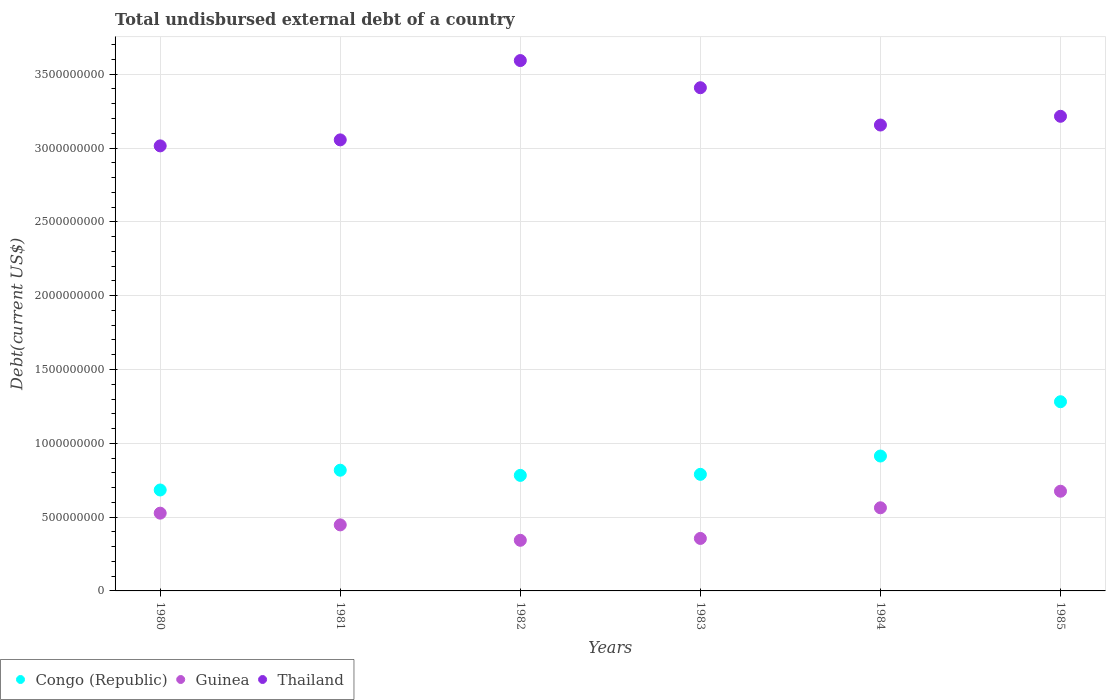What is the total undisbursed external debt in Congo (Republic) in 1985?
Provide a succinct answer. 1.28e+09. Across all years, what is the maximum total undisbursed external debt in Congo (Republic)?
Give a very brief answer. 1.28e+09. Across all years, what is the minimum total undisbursed external debt in Thailand?
Ensure brevity in your answer.  3.01e+09. In which year was the total undisbursed external debt in Thailand maximum?
Provide a short and direct response. 1982. In which year was the total undisbursed external debt in Guinea minimum?
Offer a very short reply. 1982. What is the total total undisbursed external debt in Thailand in the graph?
Your answer should be compact. 1.94e+1. What is the difference between the total undisbursed external debt in Congo (Republic) in 1983 and that in 1984?
Ensure brevity in your answer.  -1.24e+08. What is the difference between the total undisbursed external debt in Congo (Republic) in 1984 and the total undisbursed external debt in Guinea in 1985?
Provide a succinct answer. 2.38e+08. What is the average total undisbursed external debt in Guinea per year?
Offer a terse response. 4.85e+08. In the year 1984, what is the difference between the total undisbursed external debt in Thailand and total undisbursed external debt in Congo (Republic)?
Give a very brief answer. 2.24e+09. In how many years, is the total undisbursed external debt in Congo (Republic) greater than 1300000000 US$?
Offer a terse response. 0. What is the ratio of the total undisbursed external debt in Congo (Republic) in 1980 to that in 1981?
Your response must be concise. 0.84. Is the total undisbursed external debt in Guinea in 1980 less than that in 1983?
Make the answer very short. No. What is the difference between the highest and the second highest total undisbursed external debt in Guinea?
Your response must be concise. 1.12e+08. What is the difference between the highest and the lowest total undisbursed external debt in Guinea?
Give a very brief answer. 3.32e+08. Is the sum of the total undisbursed external debt in Congo (Republic) in 1980 and 1981 greater than the maximum total undisbursed external debt in Guinea across all years?
Make the answer very short. Yes. Is the total undisbursed external debt in Guinea strictly less than the total undisbursed external debt in Thailand over the years?
Keep it short and to the point. Yes. What is the difference between two consecutive major ticks on the Y-axis?
Give a very brief answer. 5.00e+08. Are the values on the major ticks of Y-axis written in scientific E-notation?
Make the answer very short. No. Does the graph contain any zero values?
Your response must be concise. No. How many legend labels are there?
Your answer should be compact. 3. How are the legend labels stacked?
Give a very brief answer. Horizontal. What is the title of the graph?
Your answer should be very brief. Total undisbursed external debt of a country. What is the label or title of the X-axis?
Your answer should be compact. Years. What is the label or title of the Y-axis?
Give a very brief answer. Debt(current US$). What is the Debt(current US$) of Congo (Republic) in 1980?
Your answer should be very brief. 6.84e+08. What is the Debt(current US$) in Guinea in 1980?
Offer a very short reply. 5.27e+08. What is the Debt(current US$) in Thailand in 1980?
Your answer should be very brief. 3.01e+09. What is the Debt(current US$) in Congo (Republic) in 1981?
Your answer should be very brief. 8.18e+08. What is the Debt(current US$) in Guinea in 1981?
Ensure brevity in your answer.  4.47e+08. What is the Debt(current US$) of Thailand in 1981?
Make the answer very short. 3.06e+09. What is the Debt(current US$) of Congo (Republic) in 1982?
Give a very brief answer. 7.83e+08. What is the Debt(current US$) in Guinea in 1982?
Provide a short and direct response. 3.43e+08. What is the Debt(current US$) of Thailand in 1982?
Your answer should be very brief. 3.59e+09. What is the Debt(current US$) of Congo (Republic) in 1983?
Offer a terse response. 7.90e+08. What is the Debt(current US$) of Guinea in 1983?
Your answer should be compact. 3.56e+08. What is the Debt(current US$) of Thailand in 1983?
Make the answer very short. 3.41e+09. What is the Debt(current US$) in Congo (Republic) in 1984?
Make the answer very short. 9.14e+08. What is the Debt(current US$) of Guinea in 1984?
Your answer should be very brief. 5.63e+08. What is the Debt(current US$) of Thailand in 1984?
Make the answer very short. 3.16e+09. What is the Debt(current US$) in Congo (Republic) in 1985?
Ensure brevity in your answer.  1.28e+09. What is the Debt(current US$) in Guinea in 1985?
Your response must be concise. 6.75e+08. What is the Debt(current US$) of Thailand in 1985?
Offer a very short reply. 3.21e+09. Across all years, what is the maximum Debt(current US$) of Congo (Republic)?
Keep it short and to the point. 1.28e+09. Across all years, what is the maximum Debt(current US$) of Guinea?
Your response must be concise. 6.75e+08. Across all years, what is the maximum Debt(current US$) of Thailand?
Your answer should be very brief. 3.59e+09. Across all years, what is the minimum Debt(current US$) in Congo (Republic)?
Your answer should be very brief. 6.84e+08. Across all years, what is the minimum Debt(current US$) in Guinea?
Your answer should be compact. 3.43e+08. Across all years, what is the minimum Debt(current US$) in Thailand?
Your answer should be very brief. 3.01e+09. What is the total Debt(current US$) in Congo (Republic) in the graph?
Your answer should be compact. 5.27e+09. What is the total Debt(current US$) of Guinea in the graph?
Your answer should be very brief. 2.91e+09. What is the total Debt(current US$) in Thailand in the graph?
Your answer should be very brief. 1.94e+1. What is the difference between the Debt(current US$) in Congo (Republic) in 1980 and that in 1981?
Your answer should be very brief. -1.34e+08. What is the difference between the Debt(current US$) of Guinea in 1980 and that in 1981?
Your answer should be compact. 7.94e+07. What is the difference between the Debt(current US$) of Thailand in 1980 and that in 1981?
Your answer should be very brief. -4.07e+07. What is the difference between the Debt(current US$) in Congo (Republic) in 1980 and that in 1982?
Keep it short and to the point. -9.89e+07. What is the difference between the Debt(current US$) in Guinea in 1980 and that in 1982?
Your response must be concise. 1.84e+08. What is the difference between the Debt(current US$) in Thailand in 1980 and that in 1982?
Keep it short and to the point. -5.78e+08. What is the difference between the Debt(current US$) in Congo (Republic) in 1980 and that in 1983?
Your answer should be compact. -1.06e+08. What is the difference between the Debt(current US$) of Guinea in 1980 and that in 1983?
Offer a very short reply. 1.71e+08. What is the difference between the Debt(current US$) of Thailand in 1980 and that in 1983?
Your answer should be compact. -3.94e+08. What is the difference between the Debt(current US$) in Congo (Republic) in 1980 and that in 1984?
Make the answer very short. -2.30e+08. What is the difference between the Debt(current US$) in Guinea in 1980 and that in 1984?
Your response must be concise. -3.64e+07. What is the difference between the Debt(current US$) of Thailand in 1980 and that in 1984?
Your answer should be compact. -1.41e+08. What is the difference between the Debt(current US$) in Congo (Republic) in 1980 and that in 1985?
Keep it short and to the point. -5.98e+08. What is the difference between the Debt(current US$) in Guinea in 1980 and that in 1985?
Your answer should be compact. -1.49e+08. What is the difference between the Debt(current US$) of Thailand in 1980 and that in 1985?
Ensure brevity in your answer.  -2.00e+08. What is the difference between the Debt(current US$) of Congo (Republic) in 1981 and that in 1982?
Keep it short and to the point. 3.50e+07. What is the difference between the Debt(current US$) in Guinea in 1981 and that in 1982?
Keep it short and to the point. 1.04e+08. What is the difference between the Debt(current US$) in Thailand in 1981 and that in 1982?
Make the answer very short. -5.37e+08. What is the difference between the Debt(current US$) of Congo (Republic) in 1981 and that in 1983?
Your response must be concise. 2.79e+07. What is the difference between the Debt(current US$) in Guinea in 1981 and that in 1983?
Make the answer very short. 9.18e+07. What is the difference between the Debt(current US$) of Thailand in 1981 and that in 1983?
Provide a short and direct response. -3.53e+08. What is the difference between the Debt(current US$) of Congo (Republic) in 1981 and that in 1984?
Give a very brief answer. -9.61e+07. What is the difference between the Debt(current US$) of Guinea in 1981 and that in 1984?
Your response must be concise. -1.16e+08. What is the difference between the Debt(current US$) in Thailand in 1981 and that in 1984?
Provide a short and direct response. -1.01e+08. What is the difference between the Debt(current US$) in Congo (Republic) in 1981 and that in 1985?
Offer a terse response. -4.64e+08. What is the difference between the Debt(current US$) in Guinea in 1981 and that in 1985?
Give a very brief answer. -2.28e+08. What is the difference between the Debt(current US$) of Thailand in 1981 and that in 1985?
Your answer should be compact. -1.60e+08. What is the difference between the Debt(current US$) in Congo (Republic) in 1982 and that in 1983?
Your answer should be very brief. -7.10e+06. What is the difference between the Debt(current US$) of Guinea in 1982 and that in 1983?
Your answer should be compact. -1.27e+07. What is the difference between the Debt(current US$) of Thailand in 1982 and that in 1983?
Make the answer very short. 1.84e+08. What is the difference between the Debt(current US$) in Congo (Republic) in 1982 and that in 1984?
Ensure brevity in your answer.  -1.31e+08. What is the difference between the Debt(current US$) in Guinea in 1982 and that in 1984?
Provide a short and direct response. -2.20e+08. What is the difference between the Debt(current US$) in Thailand in 1982 and that in 1984?
Offer a terse response. 4.37e+08. What is the difference between the Debt(current US$) in Congo (Republic) in 1982 and that in 1985?
Provide a succinct answer. -4.99e+08. What is the difference between the Debt(current US$) in Guinea in 1982 and that in 1985?
Offer a terse response. -3.32e+08. What is the difference between the Debt(current US$) in Thailand in 1982 and that in 1985?
Provide a succinct answer. 3.77e+08. What is the difference between the Debt(current US$) of Congo (Republic) in 1983 and that in 1984?
Keep it short and to the point. -1.24e+08. What is the difference between the Debt(current US$) of Guinea in 1983 and that in 1984?
Keep it short and to the point. -2.08e+08. What is the difference between the Debt(current US$) in Thailand in 1983 and that in 1984?
Offer a very short reply. 2.53e+08. What is the difference between the Debt(current US$) of Congo (Republic) in 1983 and that in 1985?
Your answer should be very brief. -4.92e+08. What is the difference between the Debt(current US$) in Guinea in 1983 and that in 1985?
Make the answer very short. -3.20e+08. What is the difference between the Debt(current US$) in Thailand in 1983 and that in 1985?
Your answer should be very brief. 1.93e+08. What is the difference between the Debt(current US$) in Congo (Republic) in 1984 and that in 1985?
Ensure brevity in your answer.  -3.68e+08. What is the difference between the Debt(current US$) in Guinea in 1984 and that in 1985?
Keep it short and to the point. -1.12e+08. What is the difference between the Debt(current US$) in Thailand in 1984 and that in 1985?
Give a very brief answer. -5.92e+07. What is the difference between the Debt(current US$) in Congo (Republic) in 1980 and the Debt(current US$) in Guinea in 1981?
Make the answer very short. 2.36e+08. What is the difference between the Debt(current US$) in Congo (Republic) in 1980 and the Debt(current US$) in Thailand in 1981?
Offer a terse response. -2.37e+09. What is the difference between the Debt(current US$) of Guinea in 1980 and the Debt(current US$) of Thailand in 1981?
Your response must be concise. -2.53e+09. What is the difference between the Debt(current US$) in Congo (Republic) in 1980 and the Debt(current US$) in Guinea in 1982?
Make the answer very short. 3.41e+08. What is the difference between the Debt(current US$) of Congo (Republic) in 1980 and the Debt(current US$) of Thailand in 1982?
Make the answer very short. -2.91e+09. What is the difference between the Debt(current US$) in Guinea in 1980 and the Debt(current US$) in Thailand in 1982?
Offer a very short reply. -3.07e+09. What is the difference between the Debt(current US$) in Congo (Republic) in 1980 and the Debt(current US$) in Guinea in 1983?
Your response must be concise. 3.28e+08. What is the difference between the Debt(current US$) in Congo (Republic) in 1980 and the Debt(current US$) in Thailand in 1983?
Offer a very short reply. -2.72e+09. What is the difference between the Debt(current US$) in Guinea in 1980 and the Debt(current US$) in Thailand in 1983?
Offer a very short reply. -2.88e+09. What is the difference between the Debt(current US$) of Congo (Republic) in 1980 and the Debt(current US$) of Guinea in 1984?
Offer a very short reply. 1.21e+08. What is the difference between the Debt(current US$) in Congo (Republic) in 1980 and the Debt(current US$) in Thailand in 1984?
Your answer should be very brief. -2.47e+09. What is the difference between the Debt(current US$) of Guinea in 1980 and the Debt(current US$) of Thailand in 1984?
Keep it short and to the point. -2.63e+09. What is the difference between the Debt(current US$) in Congo (Republic) in 1980 and the Debt(current US$) in Guinea in 1985?
Keep it short and to the point. 8.38e+06. What is the difference between the Debt(current US$) in Congo (Republic) in 1980 and the Debt(current US$) in Thailand in 1985?
Offer a terse response. -2.53e+09. What is the difference between the Debt(current US$) of Guinea in 1980 and the Debt(current US$) of Thailand in 1985?
Offer a terse response. -2.69e+09. What is the difference between the Debt(current US$) in Congo (Republic) in 1981 and the Debt(current US$) in Guinea in 1982?
Make the answer very short. 4.75e+08. What is the difference between the Debt(current US$) of Congo (Republic) in 1981 and the Debt(current US$) of Thailand in 1982?
Offer a terse response. -2.77e+09. What is the difference between the Debt(current US$) of Guinea in 1981 and the Debt(current US$) of Thailand in 1982?
Give a very brief answer. -3.15e+09. What is the difference between the Debt(current US$) of Congo (Republic) in 1981 and the Debt(current US$) of Guinea in 1983?
Provide a short and direct response. 4.62e+08. What is the difference between the Debt(current US$) of Congo (Republic) in 1981 and the Debt(current US$) of Thailand in 1983?
Make the answer very short. -2.59e+09. What is the difference between the Debt(current US$) in Guinea in 1981 and the Debt(current US$) in Thailand in 1983?
Your answer should be very brief. -2.96e+09. What is the difference between the Debt(current US$) in Congo (Republic) in 1981 and the Debt(current US$) in Guinea in 1984?
Your answer should be very brief. 2.55e+08. What is the difference between the Debt(current US$) of Congo (Republic) in 1981 and the Debt(current US$) of Thailand in 1984?
Offer a terse response. -2.34e+09. What is the difference between the Debt(current US$) in Guinea in 1981 and the Debt(current US$) in Thailand in 1984?
Offer a terse response. -2.71e+09. What is the difference between the Debt(current US$) in Congo (Republic) in 1981 and the Debt(current US$) in Guinea in 1985?
Provide a succinct answer. 1.42e+08. What is the difference between the Debt(current US$) of Congo (Republic) in 1981 and the Debt(current US$) of Thailand in 1985?
Offer a terse response. -2.40e+09. What is the difference between the Debt(current US$) in Guinea in 1981 and the Debt(current US$) in Thailand in 1985?
Your answer should be very brief. -2.77e+09. What is the difference between the Debt(current US$) of Congo (Republic) in 1982 and the Debt(current US$) of Guinea in 1983?
Give a very brief answer. 4.27e+08. What is the difference between the Debt(current US$) of Congo (Republic) in 1982 and the Debt(current US$) of Thailand in 1983?
Your response must be concise. -2.63e+09. What is the difference between the Debt(current US$) of Guinea in 1982 and the Debt(current US$) of Thailand in 1983?
Offer a terse response. -3.07e+09. What is the difference between the Debt(current US$) of Congo (Republic) in 1982 and the Debt(current US$) of Guinea in 1984?
Make the answer very short. 2.19e+08. What is the difference between the Debt(current US$) of Congo (Republic) in 1982 and the Debt(current US$) of Thailand in 1984?
Ensure brevity in your answer.  -2.37e+09. What is the difference between the Debt(current US$) of Guinea in 1982 and the Debt(current US$) of Thailand in 1984?
Offer a very short reply. -2.81e+09. What is the difference between the Debt(current US$) in Congo (Republic) in 1982 and the Debt(current US$) in Guinea in 1985?
Keep it short and to the point. 1.07e+08. What is the difference between the Debt(current US$) of Congo (Republic) in 1982 and the Debt(current US$) of Thailand in 1985?
Your response must be concise. -2.43e+09. What is the difference between the Debt(current US$) of Guinea in 1982 and the Debt(current US$) of Thailand in 1985?
Your answer should be compact. -2.87e+09. What is the difference between the Debt(current US$) in Congo (Republic) in 1983 and the Debt(current US$) in Guinea in 1984?
Offer a very short reply. 2.27e+08. What is the difference between the Debt(current US$) of Congo (Republic) in 1983 and the Debt(current US$) of Thailand in 1984?
Your answer should be very brief. -2.37e+09. What is the difference between the Debt(current US$) of Guinea in 1983 and the Debt(current US$) of Thailand in 1984?
Keep it short and to the point. -2.80e+09. What is the difference between the Debt(current US$) of Congo (Republic) in 1983 and the Debt(current US$) of Guinea in 1985?
Provide a succinct answer. 1.14e+08. What is the difference between the Debt(current US$) in Congo (Republic) in 1983 and the Debt(current US$) in Thailand in 1985?
Provide a short and direct response. -2.43e+09. What is the difference between the Debt(current US$) of Guinea in 1983 and the Debt(current US$) of Thailand in 1985?
Give a very brief answer. -2.86e+09. What is the difference between the Debt(current US$) of Congo (Republic) in 1984 and the Debt(current US$) of Guinea in 1985?
Offer a terse response. 2.38e+08. What is the difference between the Debt(current US$) of Congo (Republic) in 1984 and the Debt(current US$) of Thailand in 1985?
Make the answer very short. -2.30e+09. What is the difference between the Debt(current US$) in Guinea in 1984 and the Debt(current US$) in Thailand in 1985?
Give a very brief answer. -2.65e+09. What is the average Debt(current US$) of Congo (Republic) per year?
Your answer should be very brief. 8.78e+08. What is the average Debt(current US$) in Guinea per year?
Give a very brief answer. 4.85e+08. What is the average Debt(current US$) of Thailand per year?
Your response must be concise. 3.24e+09. In the year 1980, what is the difference between the Debt(current US$) in Congo (Republic) and Debt(current US$) in Guinea?
Ensure brevity in your answer.  1.57e+08. In the year 1980, what is the difference between the Debt(current US$) in Congo (Republic) and Debt(current US$) in Thailand?
Provide a short and direct response. -2.33e+09. In the year 1980, what is the difference between the Debt(current US$) in Guinea and Debt(current US$) in Thailand?
Offer a terse response. -2.49e+09. In the year 1981, what is the difference between the Debt(current US$) of Congo (Republic) and Debt(current US$) of Guinea?
Your answer should be compact. 3.70e+08. In the year 1981, what is the difference between the Debt(current US$) of Congo (Republic) and Debt(current US$) of Thailand?
Provide a succinct answer. -2.24e+09. In the year 1981, what is the difference between the Debt(current US$) in Guinea and Debt(current US$) in Thailand?
Your response must be concise. -2.61e+09. In the year 1982, what is the difference between the Debt(current US$) in Congo (Republic) and Debt(current US$) in Guinea?
Provide a short and direct response. 4.40e+08. In the year 1982, what is the difference between the Debt(current US$) in Congo (Republic) and Debt(current US$) in Thailand?
Give a very brief answer. -2.81e+09. In the year 1982, what is the difference between the Debt(current US$) of Guinea and Debt(current US$) of Thailand?
Keep it short and to the point. -3.25e+09. In the year 1983, what is the difference between the Debt(current US$) of Congo (Republic) and Debt(current US$) of Guinea?
Your answer should be compact. 4.34e+08. In the year 1983, what is the difference between the Debt(current US$) of Congo (Republic) and Debt(current US$) of Thailand?
Ensure brevity in your answer.  -2.62e+09. In the year 1983, what is the difference between the Debt(current US$) of Guinea and Debt(current US$) of Thailand?
Give a very brief answer. -3.05e+09. In the year 1984, what is the difference between the Debt(current US$) of Congo (Republic) and Debt(current US$) of Guinea?
Provide a succinct answer. 3.51e+08. In the year 1984, what is the difference between the Debt(current US$) of Congo (Republic) and Debt(current US$) of Thailand?
Keep it short and to the point. -2.24e+09. In the year 1984, what is the difference between the Debt(current US$) of Guinea and Debt(current US$) of Thailand?
Make the answer very short. -2.59e+09. In the year 1985, what is the difference between the Debt(current US$) in Congo (Republic) and Debt(current US$) in Guinea?
Provide a succinct answer. 6.06e+08. In the year 1985, what is the difference between the Debt(current US$) of Congo (Republic) and Debt(current US$) of Thailand?
Ensure brevity in your answer.  -1.93e+09. In the year 1985, what is the difference between the Debt(current US$) in Guinea and Debt(current US$) in Thailand?
Your response must be concise. -2.54e+09. What is the ratio of the Debt(current US$) in Congo (Republic) in 1980 to that in 1981?
Give a very brief answer. 0.84. What is the ratio of the Debt(current US$) of Guinea in 1980 to that in 1981?
Your response must be concise. 1.18. What is the ratio of the Debt(current US$) of Thailand in 1980 to that in 1981?
Offer a terse response. 0.99. What is the ratio of the Debt(current US$) in Congo (Republic) in 1980 to that in 1982?
Your response must be concise. 0.87. What is the ratio of the Debt(current US$) of Guinea in 1980 to that in 1982?
Your response must be concise. 1.54. What is the ratio of the Debt(current US$) in Thailand in 1980 to that in 1982?
Offer a very short reply. 0.84. What is the ratio of the Debt(current US$) in Congo (Republic) in 1980 to that in 1983?
Your answer should be compact. 0.87. What is the ratio of the Debt(current US$) of Guinea in 1980 to that in 1983?
Keep it short and to the point. 1.48. What is the ratio of the Debt(current US$) in Thailand in 1980 to that in 1983?
Offer a terse response. 0.88. What is the ratio of the Debt(current US$) of Congo (Republic) in 1980 to that in 1984?
Provide a short and direct response. 0.75. What is the ratio of the Debt(current US$) in Guinea in 1980 to that in 1984?
Your answer should be very brief. 0.94. What is the ratio of the Debt(current US$) of Thailand in 1980 to that in 1984?
Provide a short and direct response. 0.96. What is the ratio of the Debt(current US$) of Congo (Republic) in 1980 to that in 1985?
Your answer should be very brief. 0.53. What is the ratio of the Debt(current US$) in Guinea in 1980 to that in 1985?
Keep it short and to the point. 0.78. What is the ratio of the Debt(current US$) in Thailand in 1980 to that in 1985?
Make the answer very short. 0.94. What is the ratio of the Debt(current US$) in Congo (Republic) in 1981 to that in 1982?
Keep it short and to the point. 1.04. What is the ratio of the Debt(current US$) of Guinea in 1981 to that in 1982?
Offer a terse response. 1.3. What is the ratio of the Debt(current US$) in Thailand in 1981 to that in 1982?
Offer a very short reply. 0.85. What is the ratio of the Debt(current US$) in Congo (Republic) in 1981 to that in 1983?
Keep it short and to the point. 1.04. What is the ratio of the Debt(current US$) of Guinea in 1981 to that in 1983?
Offer a very short reply. 1.26. What is the ratio of the Debt(current US$) of Thailand in 1981 to that in 1983?
Offer a very short reply. 0.9. What is the ratio of the Debt(current US$) in Congo (Republic) in 1981 to that in 1984?
Ensure brevity in your answer.  0.89. What is the ratio of the Debt(current US$) in Guinea in 1981 to that in 1984?
Provide a succinct answer. 0.79. What is the ratio of the Debt(current US$) of Thailand in 1981 to that in 1984?
Provide a short and direct response. 0.97. What is the ratio of the Debt(current US$) of Congo (Republic) in 1981 to that in 1985?
Your answer should be compact. 0.64. What is the ratio of the Debt(current US$) of Guinea in 1981 to that in 1985?
Offer a terse response. 0.66. What is the ratio of the Debt(current US$) of Thailand in 1981 to that in 1985?
Offer a very short reply. 0.95. What is the ratio of the Debt(current US$) of Guinea in 1982 to that in 1983?
Your answer should be compact. 0.96. What is the ratio of the Debt(current US$) of Thailand in 1982 to that in 1983?
Ensure brevity in your answer.  1.05. What is the ratio of the Debt(current US$) in Congo (Republic) in 1982 to that in 1984?
Your answer should be compact. 0.86. What is the ratio of the Debt(current US$) of Guinea in 1982 to that in 1984?
Your answer should be very brief. 0.61. What is the ratio of the Debt(current US$) of Thailand in 1982 to that in 1984?
Give a very brief answer. 1.14. What is the ratio of the Debt(current US$) in Congo (Republic) in 1982 to that in 1985?
Make the answer very short. 0.61. What is the ratio of the Debt(current US$) in Guinea in 1982 to that in 1985?
Your response must be concise. 0.51. What is the ratio of the Debt(current US$) in Thailand in 1982 to that in 1985?
Offer a terse response. 1.12. What is the ratio of the Debt(current US$) of Congo (Republic) in 1983 to that in 1984?
Provide a succinct answer. 0.86. What is the ratio of the Debt(current US$) in Guinea in 1983 to that in 1984?
Ensure brevity in your answer.  0.63. What is the ratio of the Debt(current US$) in Thailand in 1983 to that in 1984?
Provide a succinct answer. 1.08. What is the ratio of the Debt(current US$) of Congo (Republic) in 1983 to that in 1985?
Ensure brevity in your answer.  0.62. What is the ratio of the Debt(current US$) in Guinea in 1983 to that in 1985?
Ensure brevity in your answer.  0.53. What is the ratio of the Debt(current US$) of Thailand in 1983 to that in 1985?
Offer a terse response. 1.06. What is the ratio of the Debt(current US$) in Congo (Republic) in 1984 to that in 1985?
Your answer should be very brief. 0.71. What is the ratio of the Debt(current US$) in Guinea in 1984 to that in 1985?
Your response must be concise. 0.83. What is the ratio of the Debt(current US$) of Thailand in 1984 to that in 1985?
Keep it short and to the point. 0.98. What is the difference between the highest and the second highest Debt(current US$) in Congo (Republic)?
Give a very brief answer. 3.68e+08. What is the difference between the highest and the second highest Debt(current US$) in Guinea?
Give a very brief answer. 1.12e+08. What is the difference between the highest and the second highest Debt(current US$) of Thailand?
Give a very brief answer. 1.84e+08. What is the difference between the highest and the lowest Debt(current US$) of Congo (Republic)?
Your answer should be very brief. 5.98e+08. What is the difference between the highest and the lowest Debt(current US$) in Guinea?
Your answer should be compact. 3.32e+08. What is the difference between the highest and the lowest Debt(current US$) in Thailand?
Make the answer very short. 5.78e+08. 